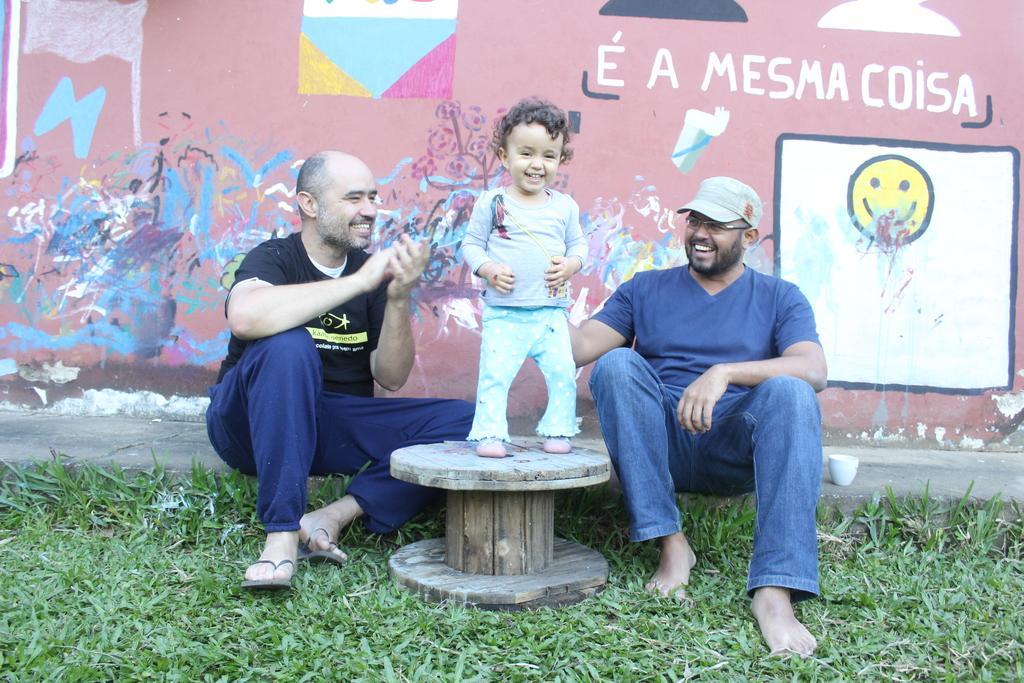Could you give a brief overview of what you see in this image? In the foreground I can see two persons are sitting on a fence and one kid is standing on a wooden wheel. In the background I can see a wall and paintings. This image is taken may be during a day on the ground. 